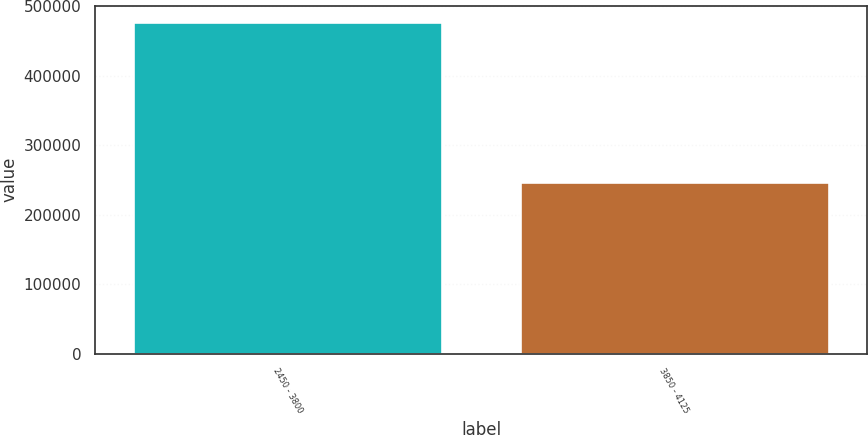Convert chart. <chart><loc_0><loc_0><loc_500><loc_500><bar_chart><fcel>2450 - 3800<fcel>3850 - 4125<nl><fcel>476683<fcel>247723<nl></chart> 